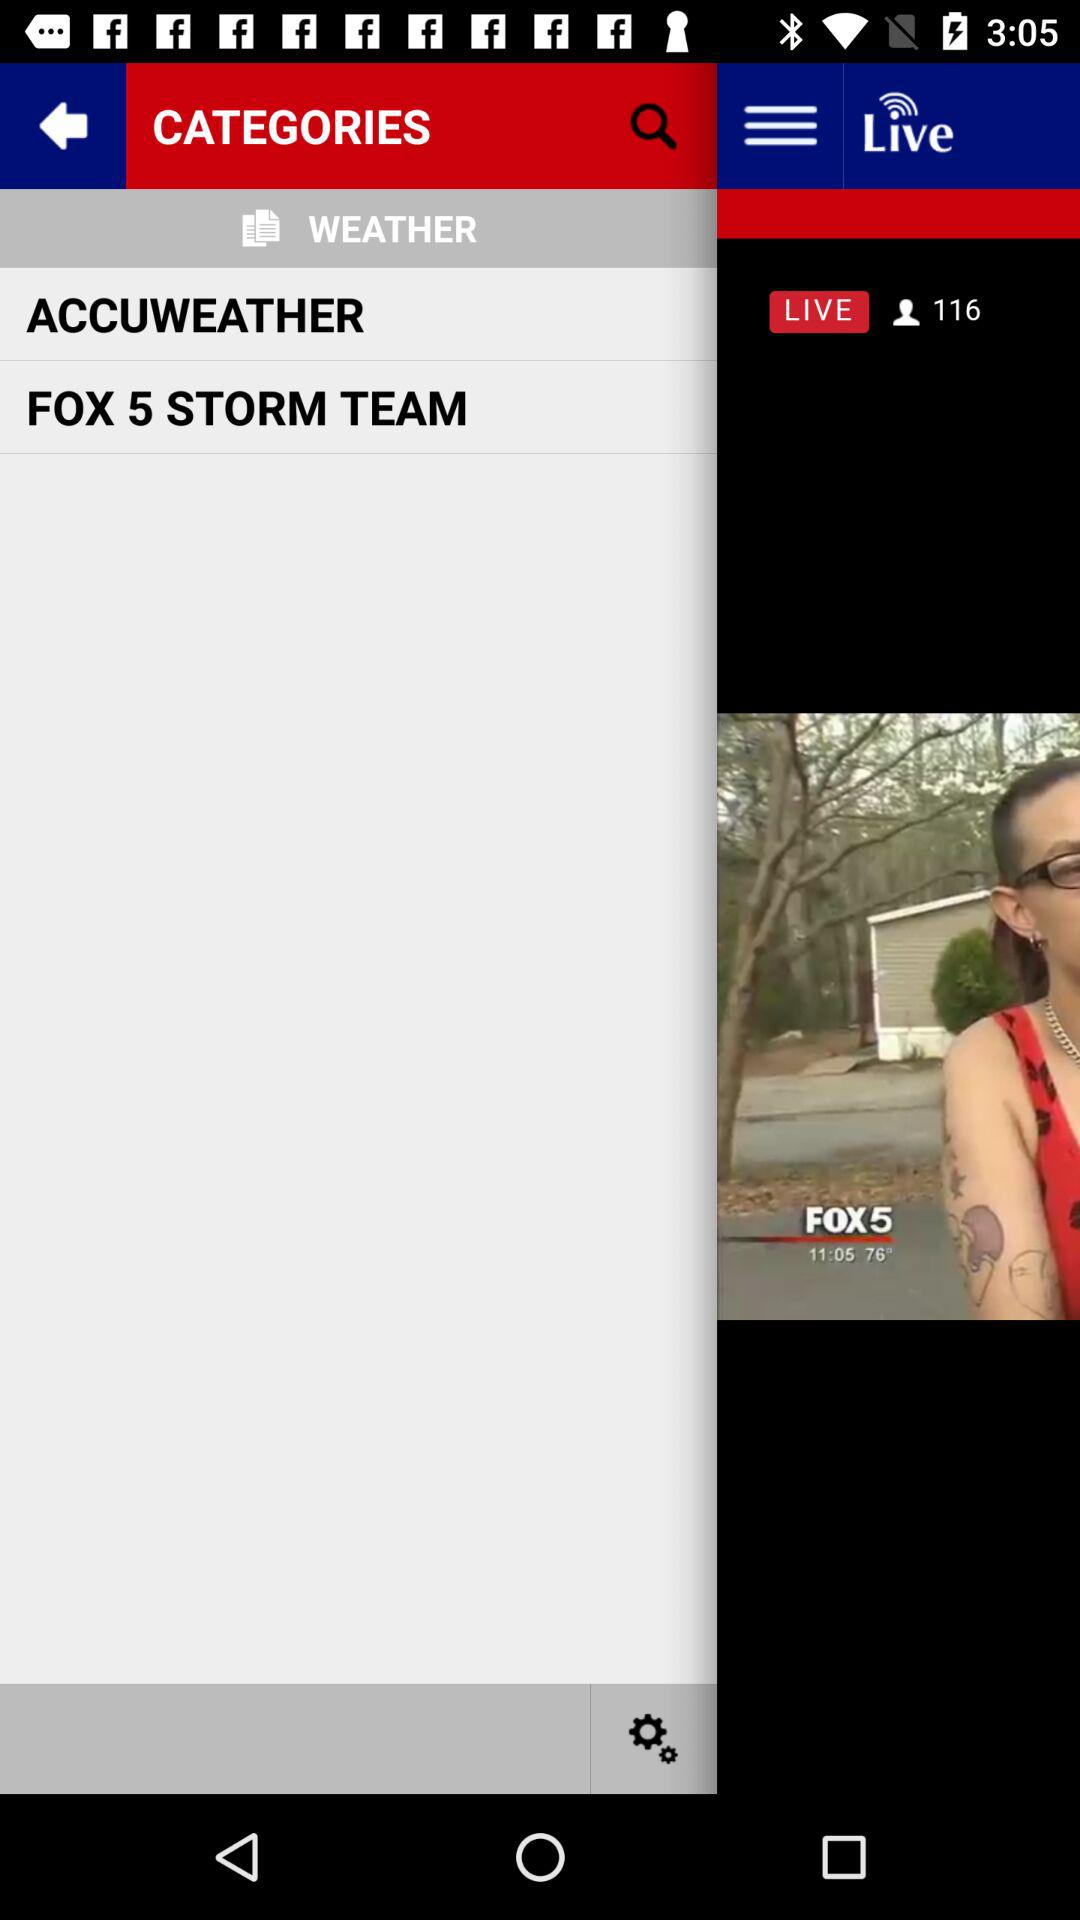Which item is selected in the menu? The selected item is "HOME". 